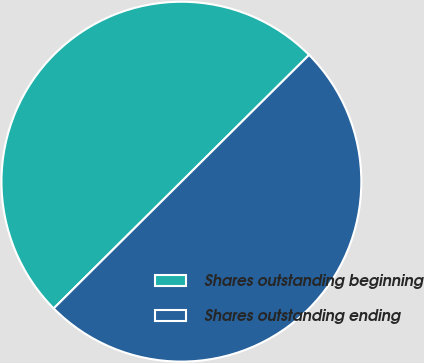Convert chart to OTSL. <chart><loc_0><loc_0><loc_500><loc_500><pie_chart><fcel>Shares outstanding beginning<fcel>Shares outstanding ending<nl><fcel>50.0%<fcel>50.0%<nl></chart> 